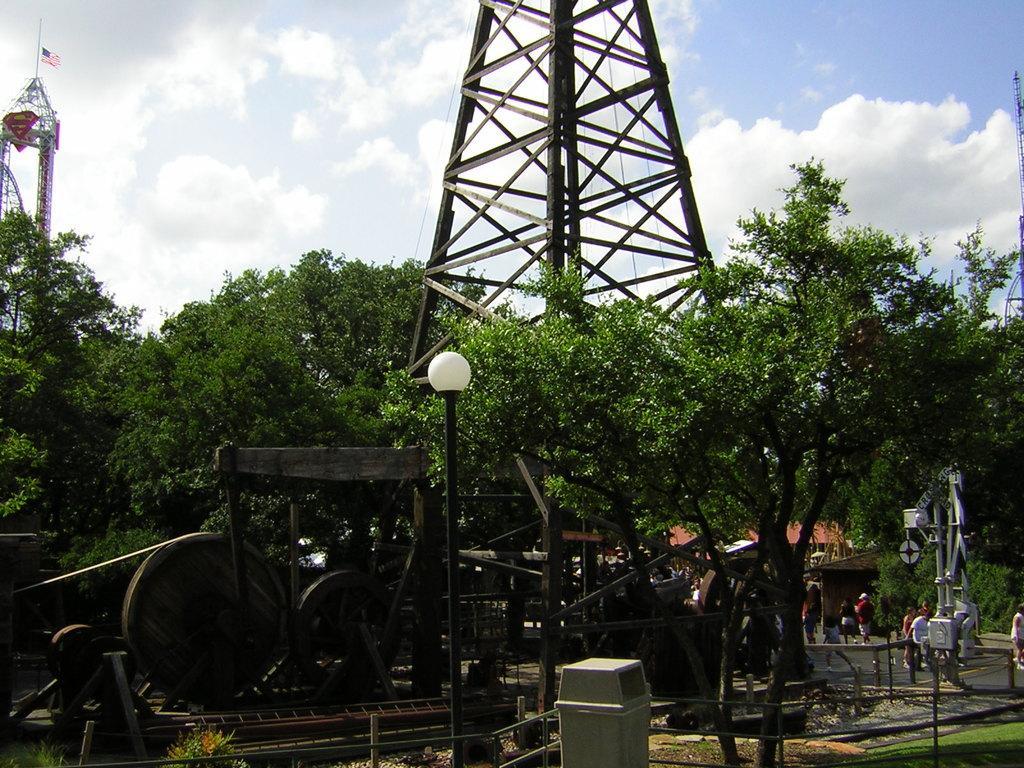Could you give a brief overview of what you see in this image? In this image, there are some towers. We can also see some vehicles and the ground. We can see some grass and objects. We can also see the track. We can also see some people and houses. There are some trees. We can see the sky with clouds. 